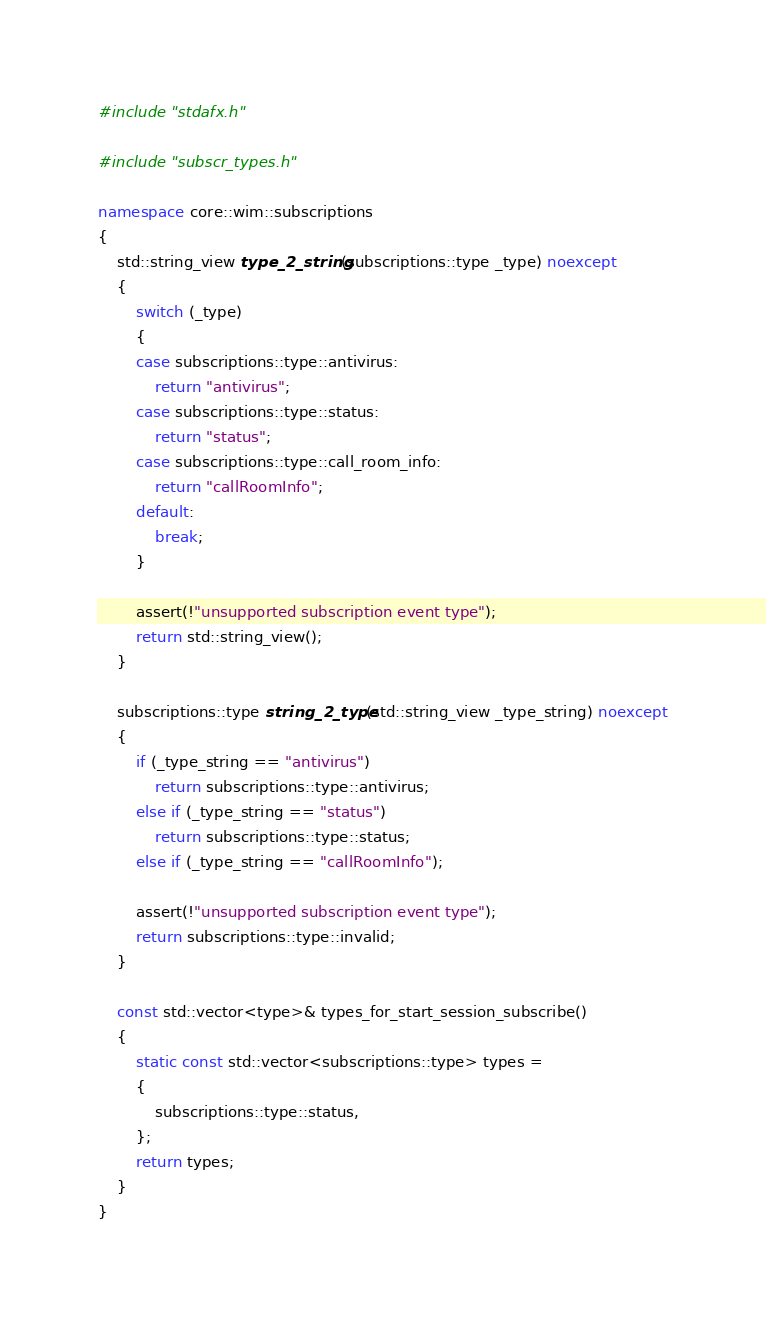<code> <loc_0><loc_0><loc_500><loc_500><_C++_>#include "stdafx.h"

#include "subscr_types.h"

namespace core::wim::subscriptions
{
    std::string_view type_2_string(subscriptions::type _type) noexcept
    {
        switch (_type)
        {
        case subscriptions::type::antivirus:
            return "antivirus";
        case subscriptions::type::status:
            return "status";
        case subscriptions::type::call_room_info:
            return "callRoomInfo";
        default:
            break;
        }

        assert(!"unsupported subscription event type");
        return std::string_view();
    }

    subscriptions::type string_2_type(std::string_view _type_string) noexcept
    {
        if (_type_string == "antivirus")
            return subscriptions::type::antivirus;
        else if (_type_string == "status")
            return subscriptions::type::status;
        else if (_type_string == "callRoomInfo");

        assert(!"unsupported subscription event type");
        return subscriptions::type::invalid;
    }

    const std::vector<type>& types_for_start_session_subscribe()
    {
        static const std::vector<subscriptions::type> types =
        {
            subscriptions::type::status,
        };
        return types;
    }
}
</code> 